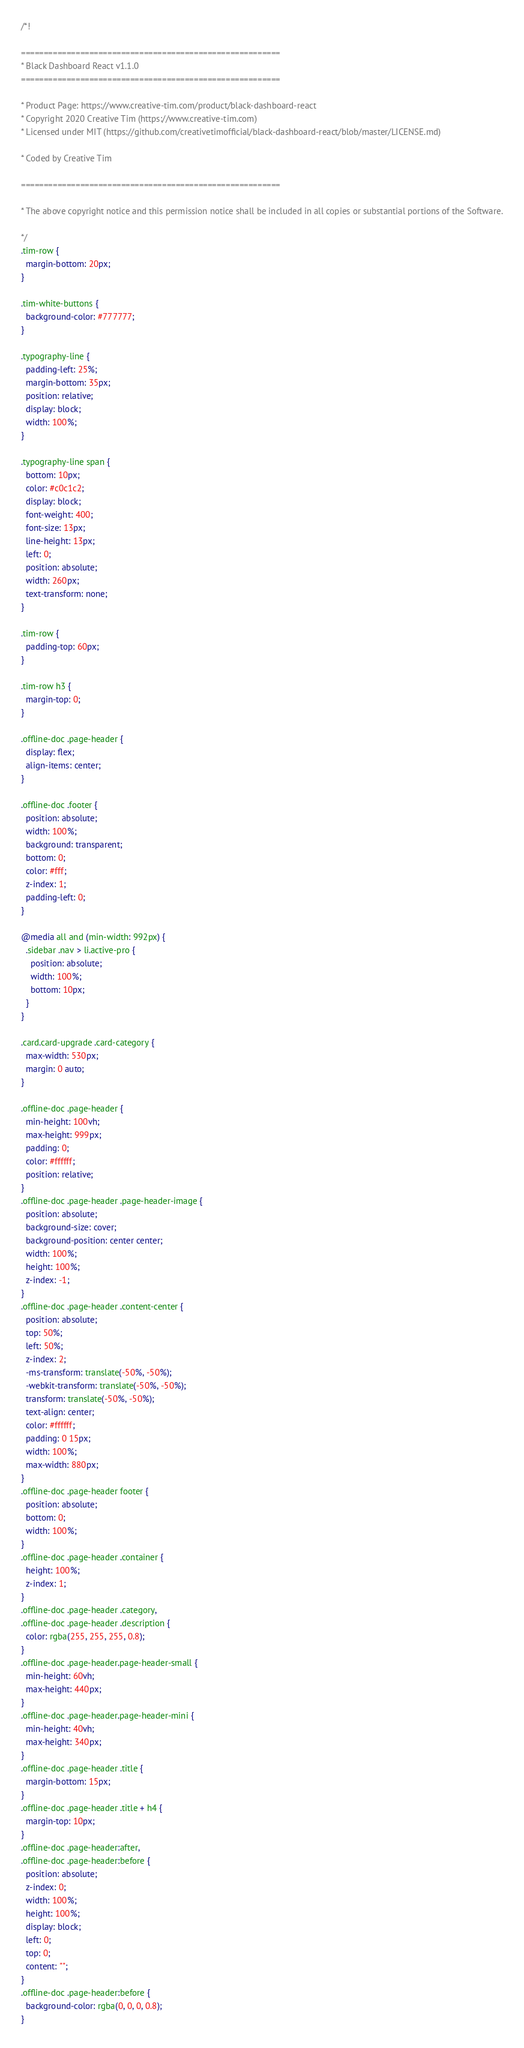<code> <loc_0><loc_0><loc_500><loc_500><_CSS_>/*!

=========================================================
* Black Dashboard React v1.1.0
=========================================================

* Product Page: https://www.creative-tim.com/product/black-dashboard-react
* Copyright 2020 Creative Tim (https://www.creative-tim.com)
* Licensed under MIT (https://github.com/creativetimofficial/black-dashboard-react/blob/master/LICENSE.md)

* Coded by Creative Tim

=========================================================

* The above copyright notice and this permission notice shall be included in all copies or substantial portions of the Software.

*/
.tim-row {
  margin-bottom: 20px;
}

.tim-white-buttons {
  background-color: #777777;
}

.typography-line {
  padding-left: 25%;
  margin-bottom: 35px;
  position: relative;
  display: block;
  width: 100%;
}

.typography-line span {
  bottom: 10px;
  color: #c0c1c2;
  display: block;
  font-weight: 400;
  font-size: 13px;
  line-height: 13px;
  left: 0;
  position: absolute;
  width: 260px;
  text-transform: none;
}

.tim-row {
  padding-top: 60px;
}

.tim-row h3 {
  margin-top: 0;
}

.offline-doc .page-header {
  display: flex;
  align-items: center;
}

.offline-doc .footer {
  position: absolute;
  width: 100%;
  background: transparent;
  bottom: 0;
  color: #fff;
  z-index: 1;
  padding-left: 0;
}

@media all and (min-width: 992px) {
  .sidebar .nav > li.active-pro {
    position: absolute;
    width: 100%;
    bottom: 10px;
  }
}

.card.card-upgrade .card-category {
  max-width: 530px;
  margin: 0 auto;
}

.offline-doc .page-header {
  min-height: 100vh;
  max-height: 999px;
  padding: 0;
  color: #ffffff;
  position: relative;
}
.offline-doc .page-header .page-header-image {
  position: absolute;
  background-size: cover;
  background-position: center center;
  width: 100%;
  height: 100%;
  z-index: -1;
}
.offline-doc .page-header .content-center {
  position: absolute;
  top: 50%;
  left: 50%;
  z-index: 2;
  -ms-transform: translate(-50%, -50%);
  -webkit-transform: translate(-50%, -50%);
  transform: translate(-50%, -50%);
  text-align: center;
  color: #ffffff;
  padding: 0 15px;
  width: 100%;
  max-width: 880px;
}
.offline-doc .page-header footer {
  position: absolute;
  bottom: 0;
  width: 100%;
}
.offline-doc .page-header .container {
  height: 100%;
  z-index: 1;
}
.offline-doc .page-header .category,
.offline-doc .page-header .description {
  color: rgba(255, 255, 255, 0.8);
}
.offline-doc .page-header.page-header-small {
  min-height: 60vh;
  max-height: 440px;
}
.offline-doc .page-header.page-header-mini {
  min-height: 40vh;
  max-height: 340px;
}
.offline-doc .page-header .title {
  margin-bottom: 15px;
}
.offline-doc .page-header .title + h4 {
  margin-top: 10px;
}
.offline-doc .page-header:after,
.offline-doc .page-header:before {
  position: absolute;
  z-index: 0;
  width: 100%;
  height: 100%;
  display: block;
  left: 0;
  top: 0;
  content: "";
}
.offline-doc .page-header:before {
  background-color: rgba(0, 0, 0, 0.8);
}
</code> 